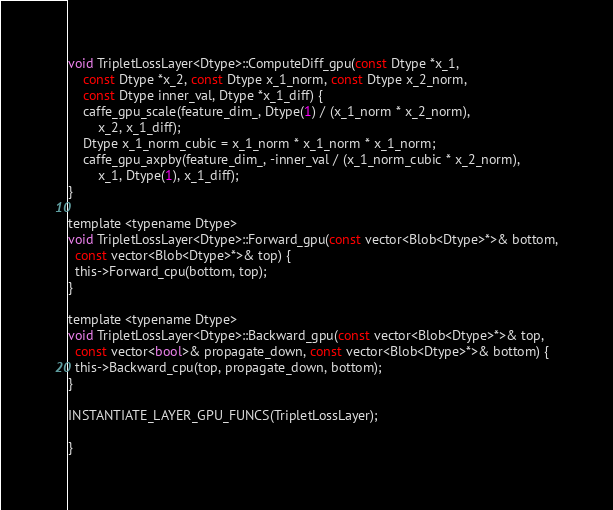Convert code to text. <code><loc_0><loc_0><loc_500><loc_500><_Cuda_>void TripletLossLayer<Dtype>::ComputeDiff_gpu(const Dtype *x_1,
    const Dtype *x_2, const Dtype x_1_norm, const Dtype x_2_norm,
    const Dtype inner_val, Dtype *x_1_diff) {
    caffe_gpu_scale(feature_dim_, Dtype(1) / (x_1_norm * x_2_norm),
        x_2, x_1_diff);
    Dtype x_1_norm_cubic = x_1_norm * x_1_norm * x_1_norm;
    caffe_gpu_axpby(feature_dim_, -inner_val / (x_1_norm_cubic * x_2_norm),
        x_1, Dtype(1), x_1_diff);
}

template <typename Dtype>
void TripletLossLayer<Dtype>::Forward_gpu(const vector<Blob<Dtype>*>& bottom,
  const vector<Blob<Dtype>*>& top) {
  this->Forward_cpu(bottom, top);
}

template <typename Dtype>
void TripletLossLayer<Dtype>::Backward_gpu(const vector<Blob<Dtype>*>& top,
  const vector<bool>& propagate_down, const vector<Blob<Dtype>*>& bottom) {
  this->Backward_cpu(top, propagate_down, bottom);
}

INSTANTIATE_LAYER_GPU_FUNCS(TripletLossLayer);

}
</code> 